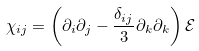<formula> <loc_0><loc_0><loc_500><loc_500>\chi _ { i j } = \left ( \partial _ { i } \partial _ { j } - \frac { \delta _ { i j } } 3 \partial _ { k } \partial _ { k } \right ) \mathcal { E }</formula> 